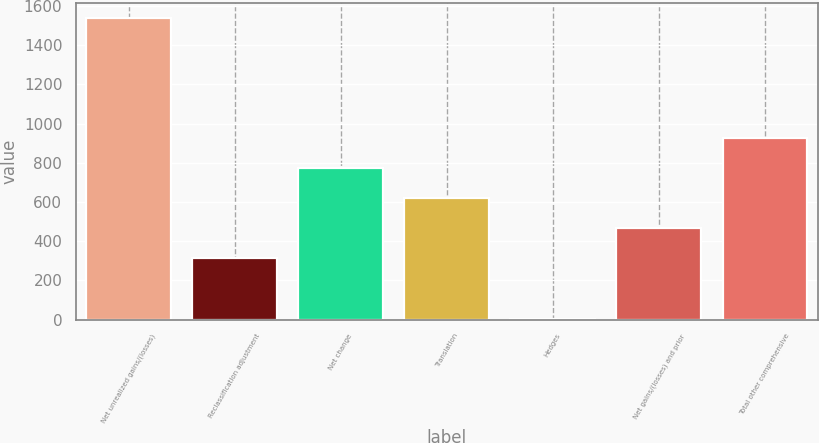Convert chart to OTSL. <chart><loc_0><loc_0><loc_500><loc_500><bar_chart><fcel>Net unrealized gains/(losses)<fcel>Reclassification adjustment<fcel>Net change<fcel>Translation<fcel>Hedges<fcel>Net gains/(losses) and prior<fcel>Total other comprehensive<nl><fcel>1540<fcel>312<fcel>772.5<fcel>619<fcel>5<fcel>465.5<fcel>926<nl></chart> 